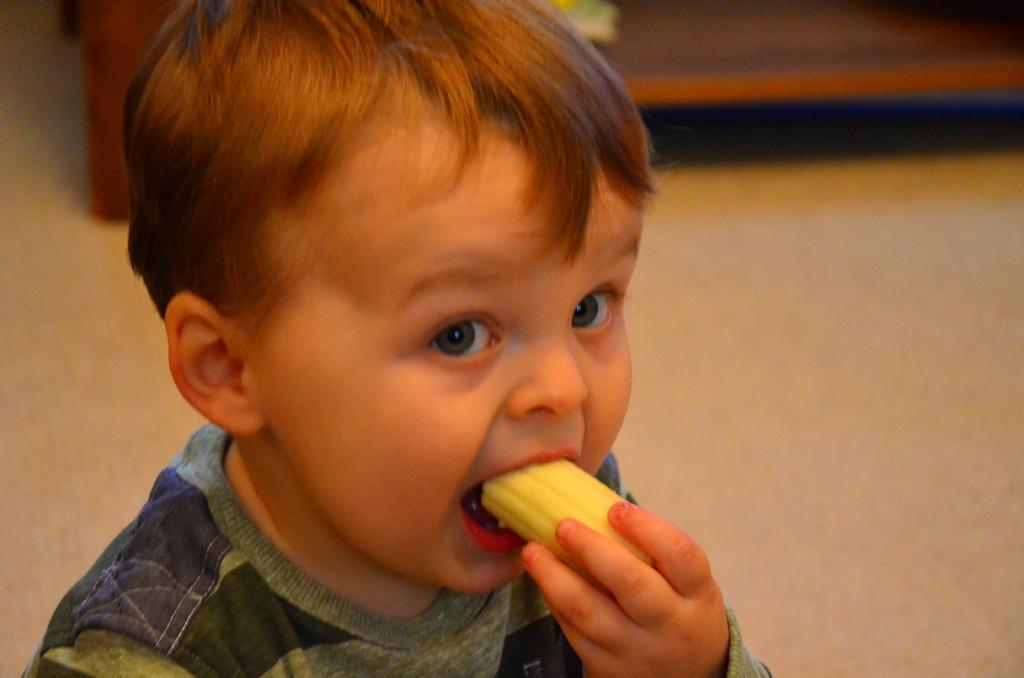How would you summarize this image in a sentence or two? There is a small child eating a piece of banana. In the background there is floor and it is blurred. 